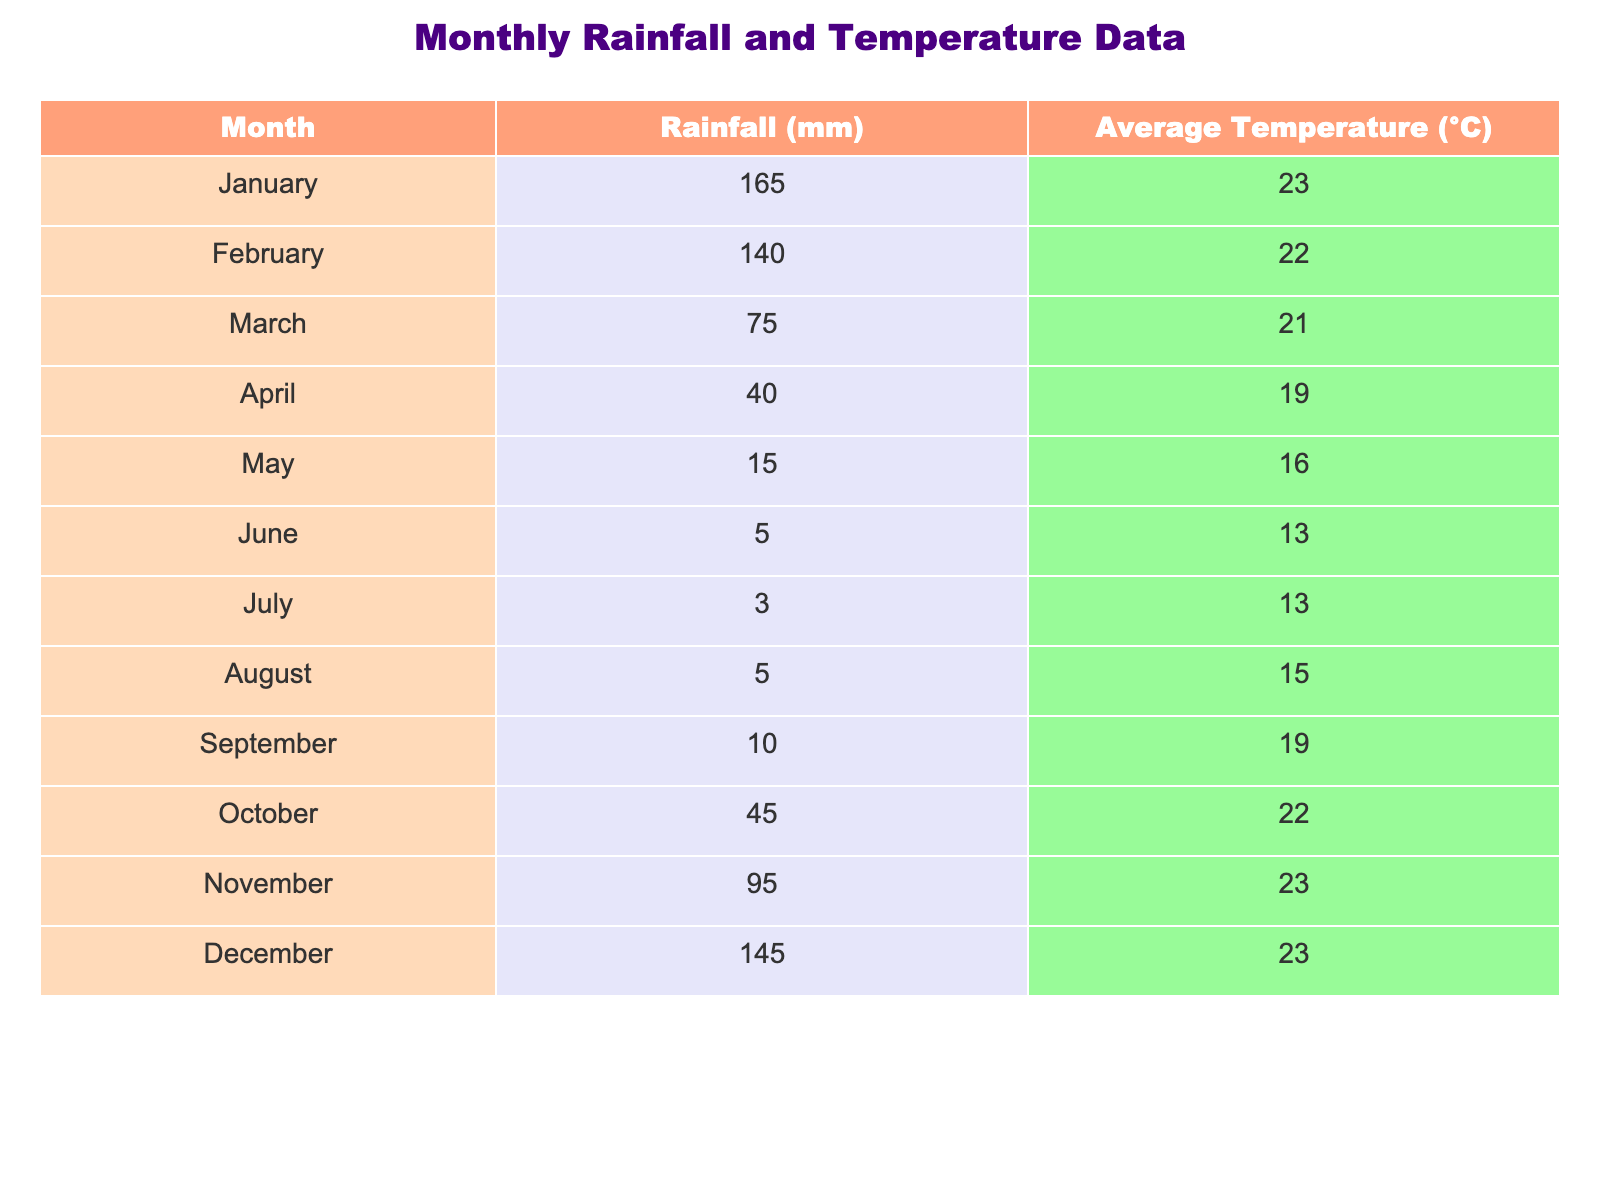What is the highest amount of rainfall recorded in a month? By looking at the table, we can see the values under the "Rainfall (mm)" column. The maximum value is 165 mm for January.
Answer: 165 mm Which month has the lowest average temperature? In the "Average Temperature (°C)" column, the lowest recorded temperature is 13 °C, occurring in both June and July.
Answer: 13 °C How much rainfall was recorded in October? October has a rainfall value of 45 mm, as indicated in the table under the "Rainfall (mm)" column.
Answer: 45 mm What is the total rainfall from May to August? To get the total rainfall from May to August, we add the values: 15 mm (May) + 5 mm (June) + 3 mm (July) + 5 mm (August) = 28 mm.
Answer: 28 mm Is the average temperature in December higher than in April? December has an average temperature of 23 °C, while April has an average temperature of 19 °C. Thus, the average temperature in December is higher.
Answer: Yes What is the average rainfall for the months of January and February? The rainfall for January is 165 mm and for February is 140 mm. The average is calculated as (165 + 140) / 2 = 152.5 mm.
Answer: 152.5 mm How many months recorded less than 10 mm of rainfall? According to the table, only July (3 mm) has less than 10 mm, while August (5 mm) also fits this criterion. So there are 2 months.
Answer: 2 months Which month has the highest average temperature? From the "Average Temperature (°C)" column, we see that January and December both have the highest temperature recorded at 23 °C.
Answer: 23 °C What is the difference in average temperature between January and March? January has an average temperature of 23 °C, while March has 21 °C. The difference is 23 - 21 = 2 °C.
Answer: 2 °C Combining the rainfall for January, February, and March, what is the total? The total for those months is 165 mm (January) + 140 mm (February) + 75 mm (March) = 380 mm.
Answer: 380 mm 